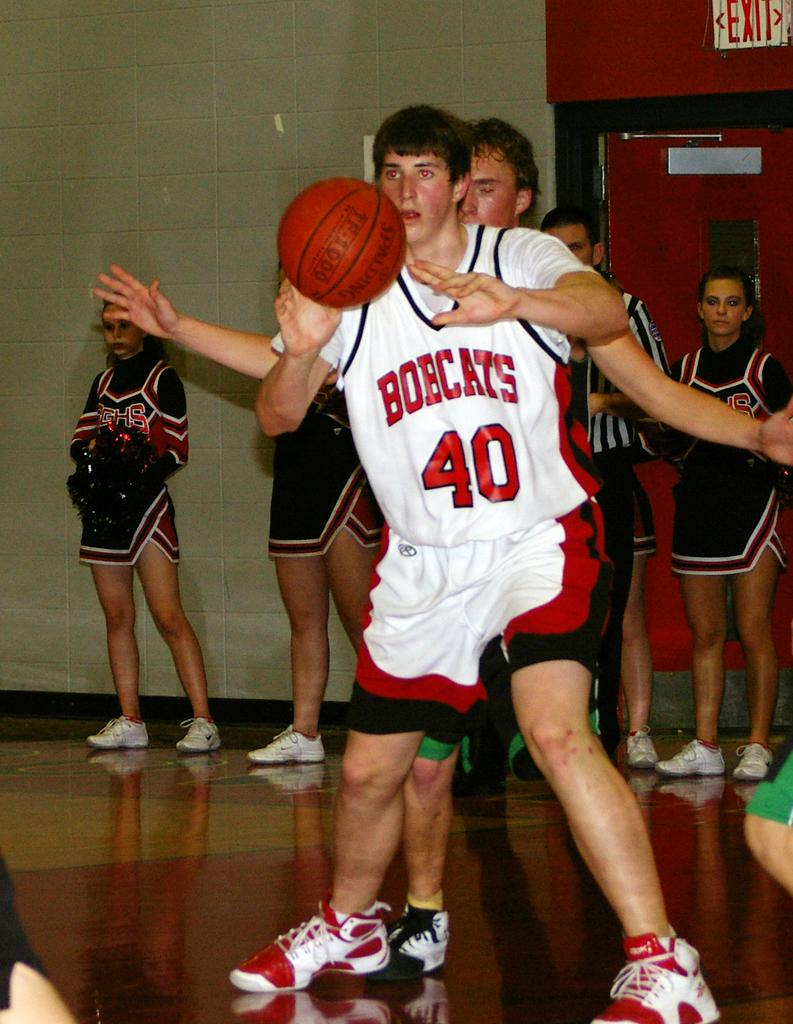Provide a one-sentence caption for the provided image. Bobcats number 40 attempts to keep control of the basketball. 